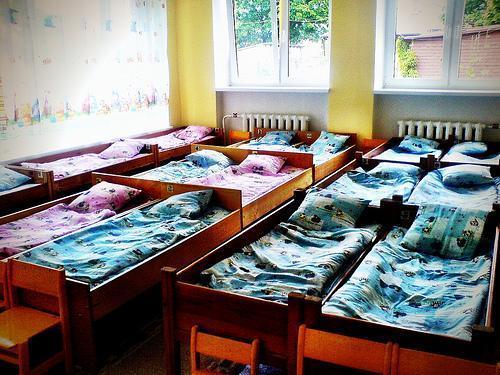How many curtains are shown?
Give a very brief answer. 2. How many babies are sleeping in the bed?
Give a very brief answer. 0. 